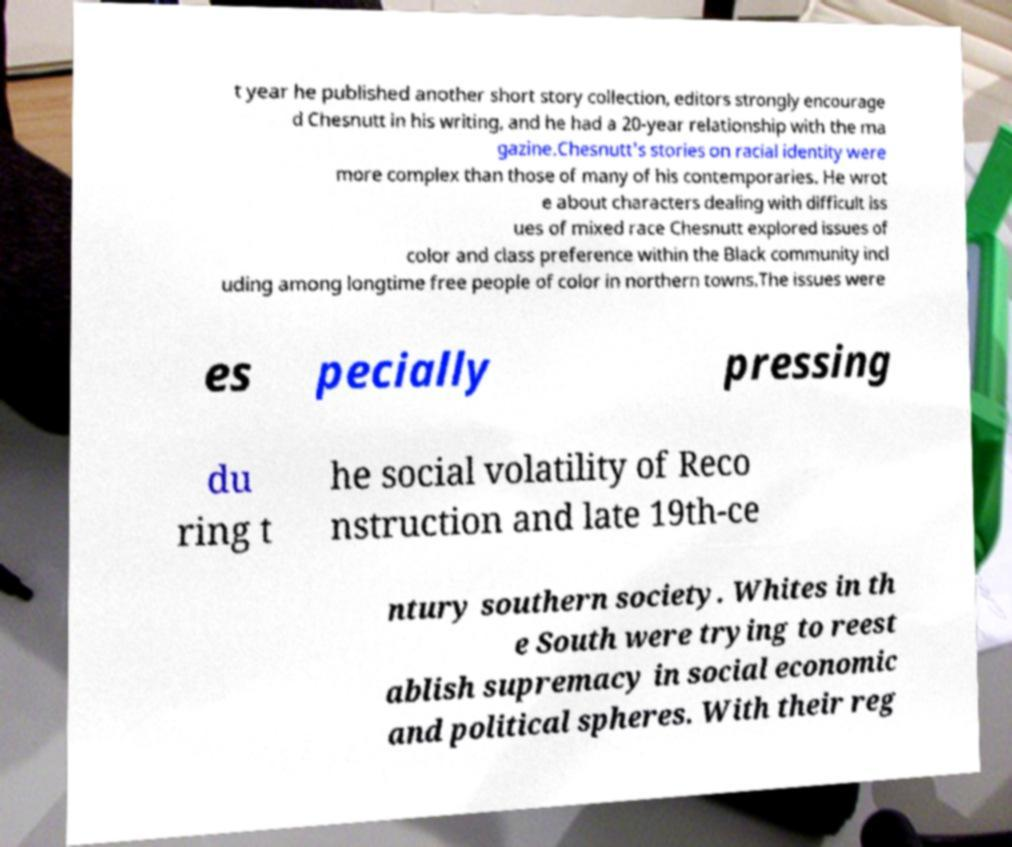For documentation purposes, I need the text within this image transcribed. Could you provide that? t year he published another short story collection, editors strongly encourage d Chesnutt in his writing, and he had a 20-year relationship with the ma gazine.Chesnutt's stories on racial identity were more complex than those of many of his contemporaries. He wrot e about characters dealing with difficult iss ues of mixed race Chesnutt explored issues of color and class preference within the Black community incl uding among longtime free people of color in northern towns.The issues were es pecially pressing du ring t he social volatility of Reco nstruction and late 19th-ce ntury southern society. Whites in th e South were trying to reest ablish supremacy in social economic and political spheres. With their reg 